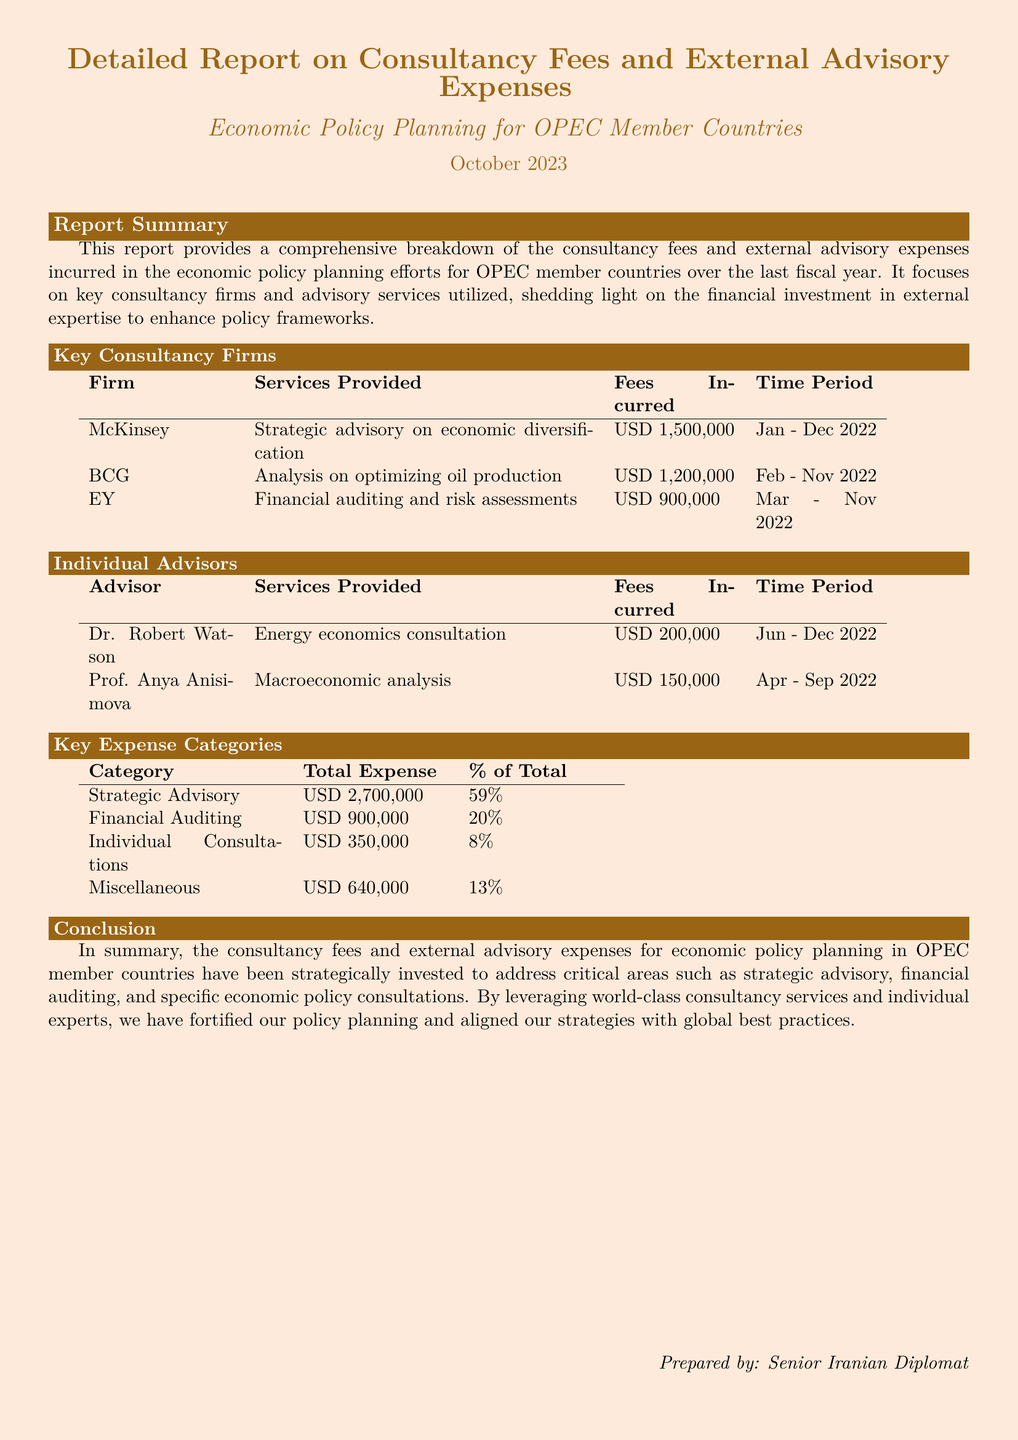What is the total consultancy fee incurred? The total consultancy fee is found in the report summary and breakdown tables, combining the fees of all firms and advisors listed.
Answer: USD 5,650,000 Which firm provided strategic advisory on economic diversification? This information is stated under the key consultancy firms where each firm's services are outlined.
Answer: McKinsey What percentage of total expenses is attributed to strategic advisory? The percentage is given in the table outlining key expense categories, indicating how much each category contributed to the overall expenses.
Answer: 59% Who is the advisor for energy economics consultation? This refers to the individual listed in the Individual Advisors section providing specific services.
Answer: Dr. Robert Watson What is the total expense for financial auditing? This is specified directly in the key expense categories table under total expenses for that category.
Answer: USD 900,000 How many individual consultations were listed in the report? This can be determined by counting the entries in the Individual Advisors section of the document.
Answer: 2 Which period is covered by McKinsey's consultancy fees? The time period during which the services were rendered can be found in the key consultancy firms table.
Answer: Jan - Dec 2022 What is the total expenditure on miscellaneous expenses? The figure is provided in the key expense categories table as it outlines total expenses for each category.
Answer: USD 640,000 